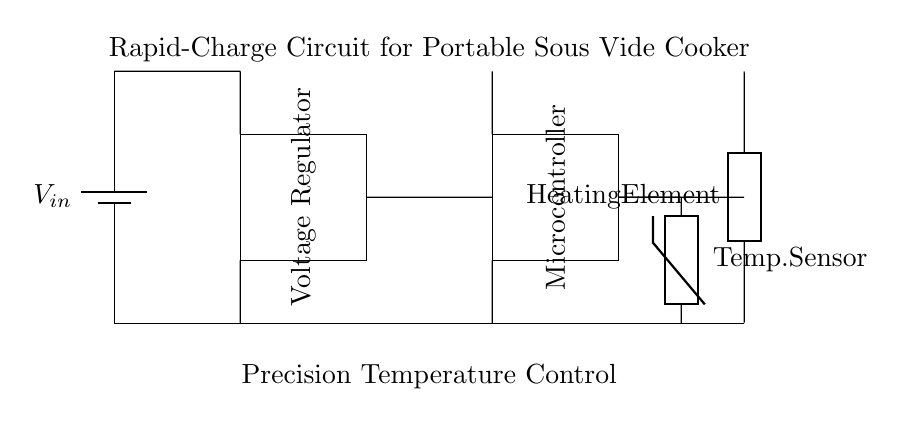What is the main power source in this circuit? The main power source is labeled as the battery in the circuit diagram. It is located at the left side of the diagram and provides the input voltage, denoted as V in.
Answer: Battery What type of component is used for temperature sensing? The component used for temperature sensing is a thermistor, as indicated in the circuit diagram. It is connected to the heating element to monitor temperature.
Answer: Thermistor How many main components are shown in the circuit? There are four main components depicted in the circuit: a battery, a voltage regulator, a microcontroller, and a heating element. Each component has a distinct function in the rapid-charge circuit.
Answer: Four What function does the voltage regulator serve in this circuit? The voltage regulator's function is to provide a stable output voltage to the microcontroller and heating element, ensuring they operate within their required voltage levels.
Answer: Stabilizes voltage Which component connects the battery to the heating element? The connection from the battery to the heating element comes through the voltage regulator and the microcontroller, creating a pathway for current to flow to the heating element.
Answer: Voltage regulator and microcontroller What is the relationship between the temperature sensor and the heating element? The temperature sensor monitors the temperature of the heating element and provides feedback to the microcontroller, which helps in precision cooking by adjusting heating as necessary.
Answer: Feedback control What does the label 'Precision Temperature Control' imply about the functionality? The label indicates that the circuit is designed to maintain the temperature of the water in the sous vide cooker at a precise level, which is essential for achieving optimal cooking results.
Answer: Precision cooking 